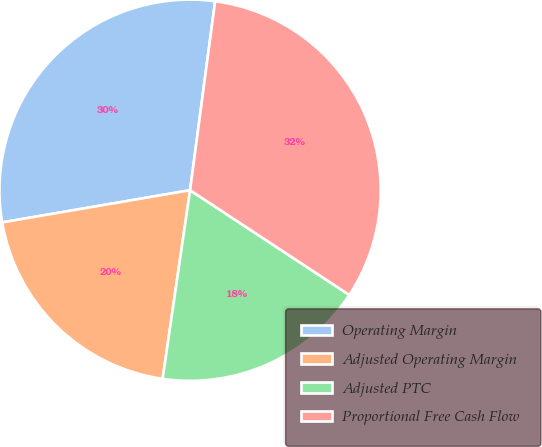Convert chart. <chart><loc_0><loc_0><loc_500><loc_500><pie_chart><fcel>Operating Margin<fcel>Adjusted Operating Margin<fcel>Adjusted PTC<fcel>Proportional Free Cash Flow<nl><fcel>29.8%<fcel>20.0%<fcel>18.04%<fcel>32.16%<nl></chart> 